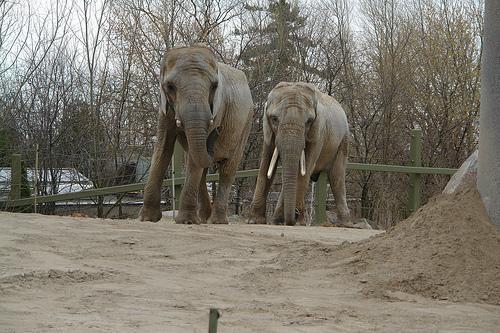How many elephants?
Give a very brief answer. 2. 